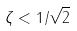<formula> <loc_0><loc_0><loc_500><loc_500>\zeta < 1 / \sqrt { 2 }</formula> 